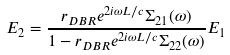<formula> <loc_0><loc_0><loc_500><loc_500>E _ { 2 } = \frac { r _ { D B R } e ^ { 2 i \omega L / c } \Sigma _ { 2 1 } ( \omega ) } { 1 - r _ { D B R } e ^ { 2 i \omega L / c } \Sigma _ { 2 2 } ( \omega ) } E _ { 1 }</formula> 